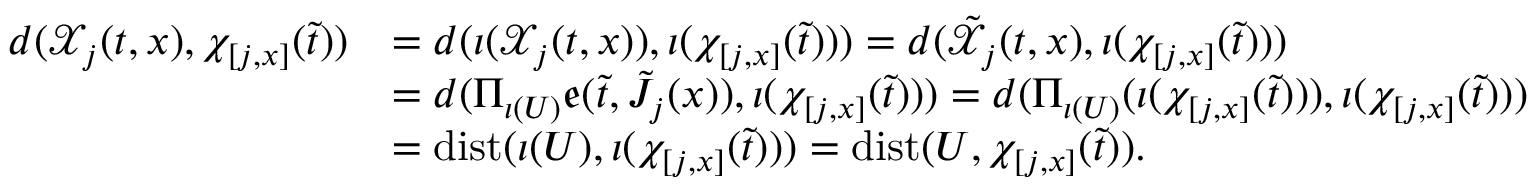Convert formula to latex. <formula><loc_0><loc_0><loc_500><loc_500>\begin{array} { r l } { d ( \mathcal { X } _ { j } ( t , x ) , \chi _ { [ j , x ] } ( \tilde { t } ) ) } & { = d ( \iota ( \mathcal { X } _ { j } ( t , x ) ) , \iota ( \chi _ { [ j , x ] } ( \tilde { t } ) ) ) = d ( \tilde { \mathcal { X } } _ { j } ( t , x ) , \iota ( \chi _ { [ j , x ] } ( \tilde { t } ) ) ) } \\ & { = d ( \Pi _ { \iota ( U ) } \mathfrak { e } ( \tilde { t } , \tilde { J } _ { j } ( x ) ) , \iota ( \chi _ { [ j , x ] } ( \tilde { t } ) ) ) = d ( \Pi _ { \iota ( U ) } ( \iota ( \chi _ { [ j , x ] } ( \tilde { t } ) ) ) , \iota ( \chi _ { [ j , x ] } ( \tilde { t } ) ) ) } \\ & { = d i s t ( \iota ( U ) , \iota ( \chi _ { [ j , x ] } ( \tilde { t } ) ) ) = d i s t ( U , \chi _ { [ j , x ] } ( \tilde { t } ) ) . } \end{array}</formula> 